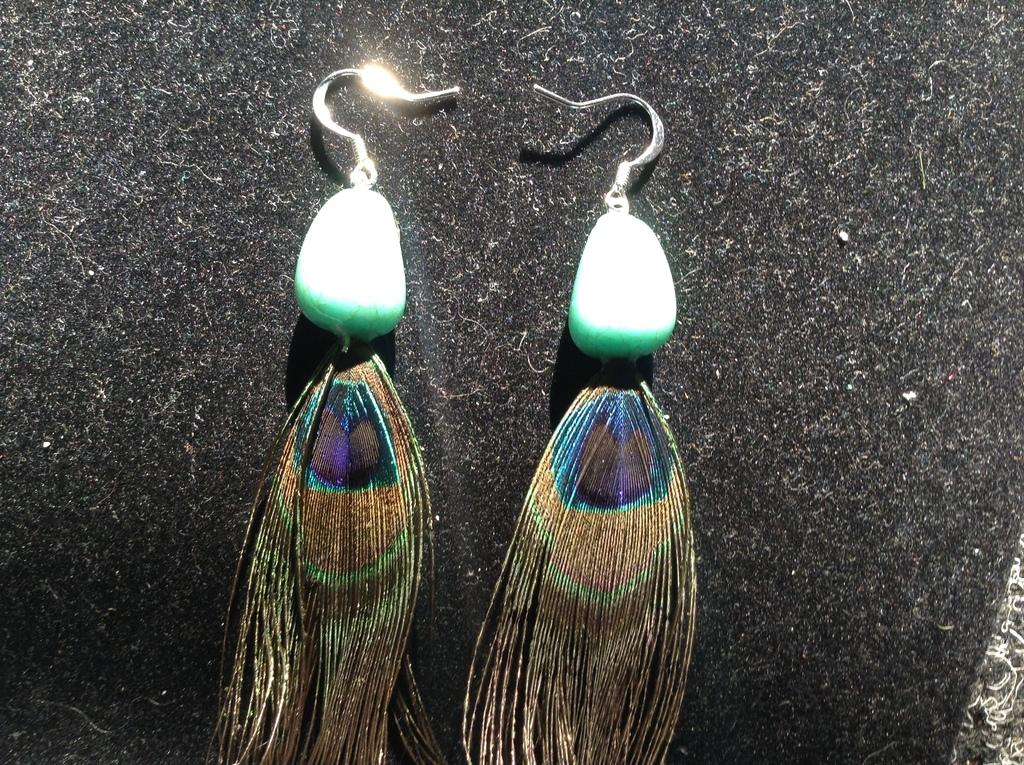What type of accessory is visible in the image? There are earrings in the image. Can you describe the background of the image? There is a sponge in the background of the image. What type of hat is being worn by the person in the image? There is no person or hat present in the image; it only features earrings and a sponge in the background. 